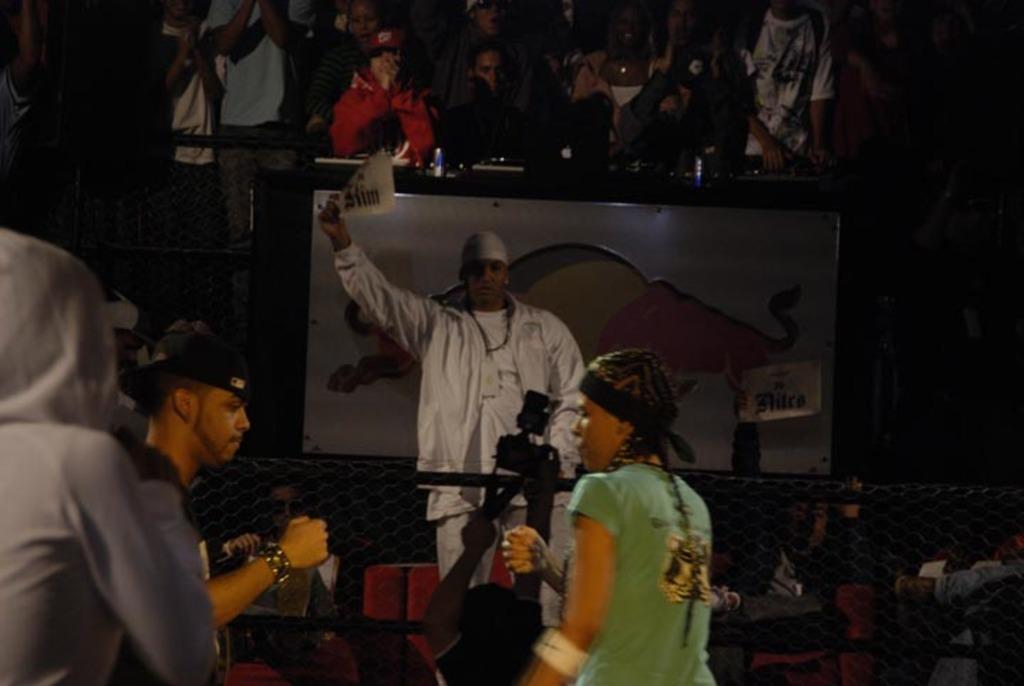Describe this image in one or two sentences. In this image I can see a group of people, screen, fence, objects and a board. This image is taken may be during night. 